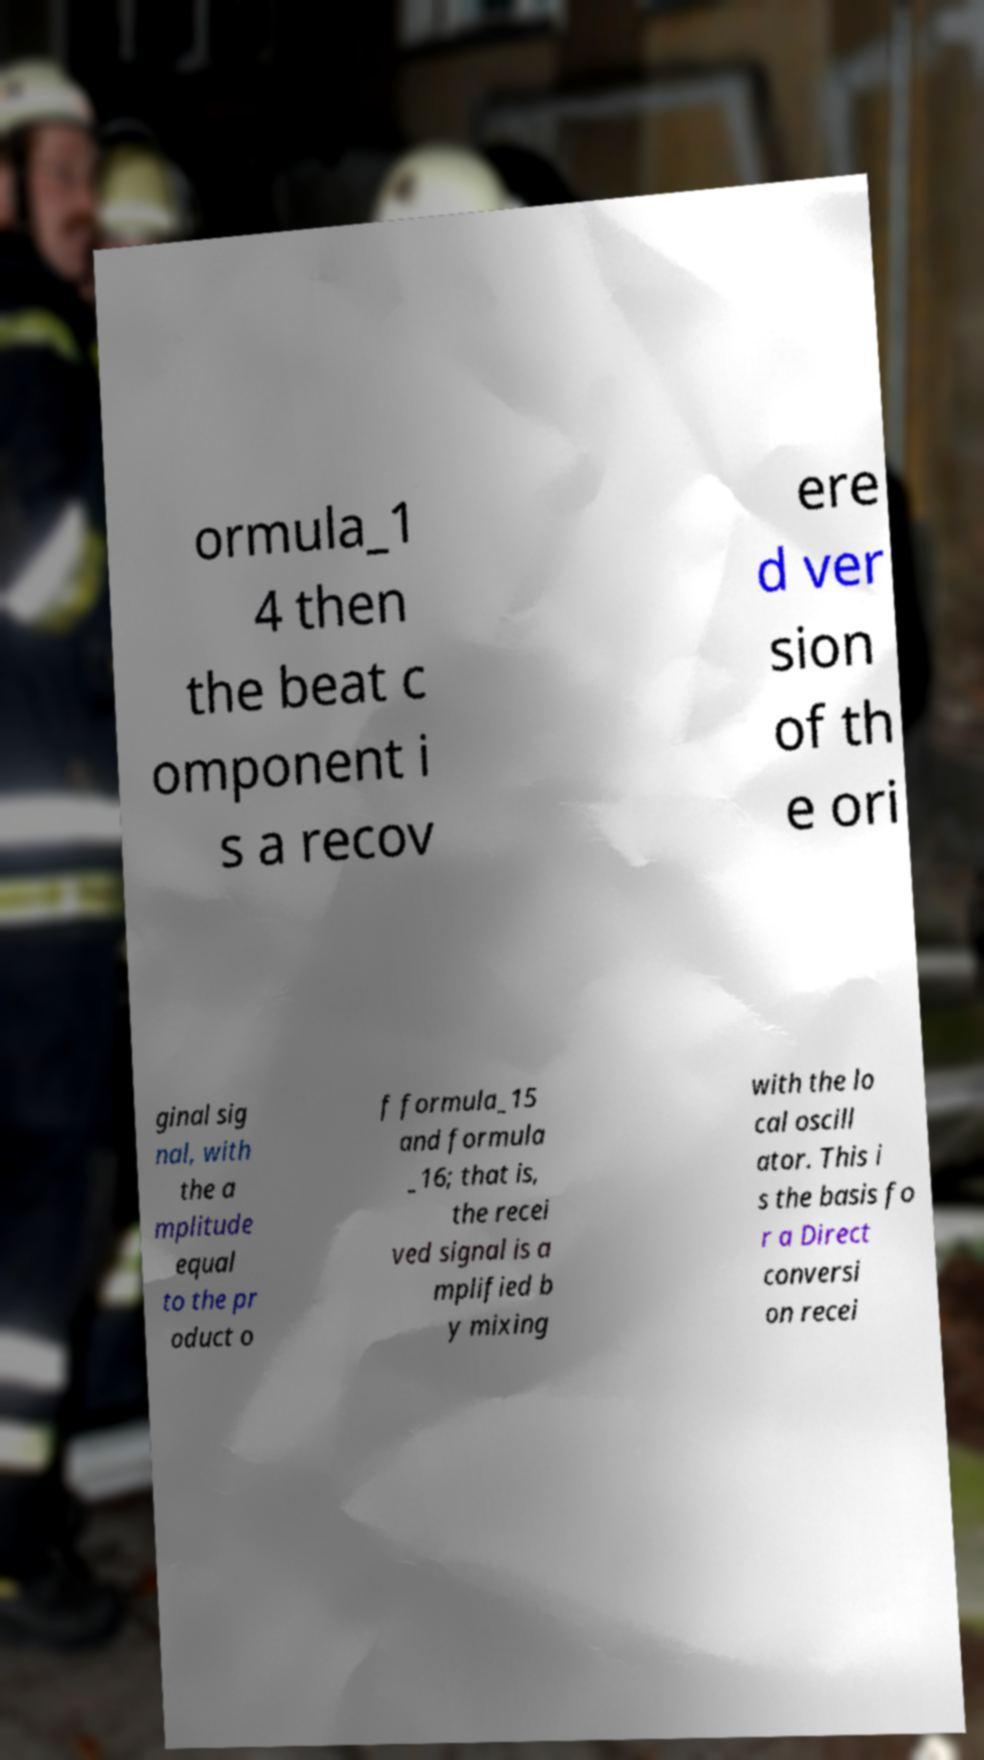For documentation purposes, I need the text within this image transcribed. Could you provide that? ormula_1 4 then the beat c omponent i s a recov ere d ver sion of th e ori ginal sig nal, with the a mplitude equal to the pr oduct o f formula_15 and formula _16; that is, the recei ved signal is a mplified b y mixing with the lo cal oscill ator. This i s the basis fo r a Direct conversi on recei 